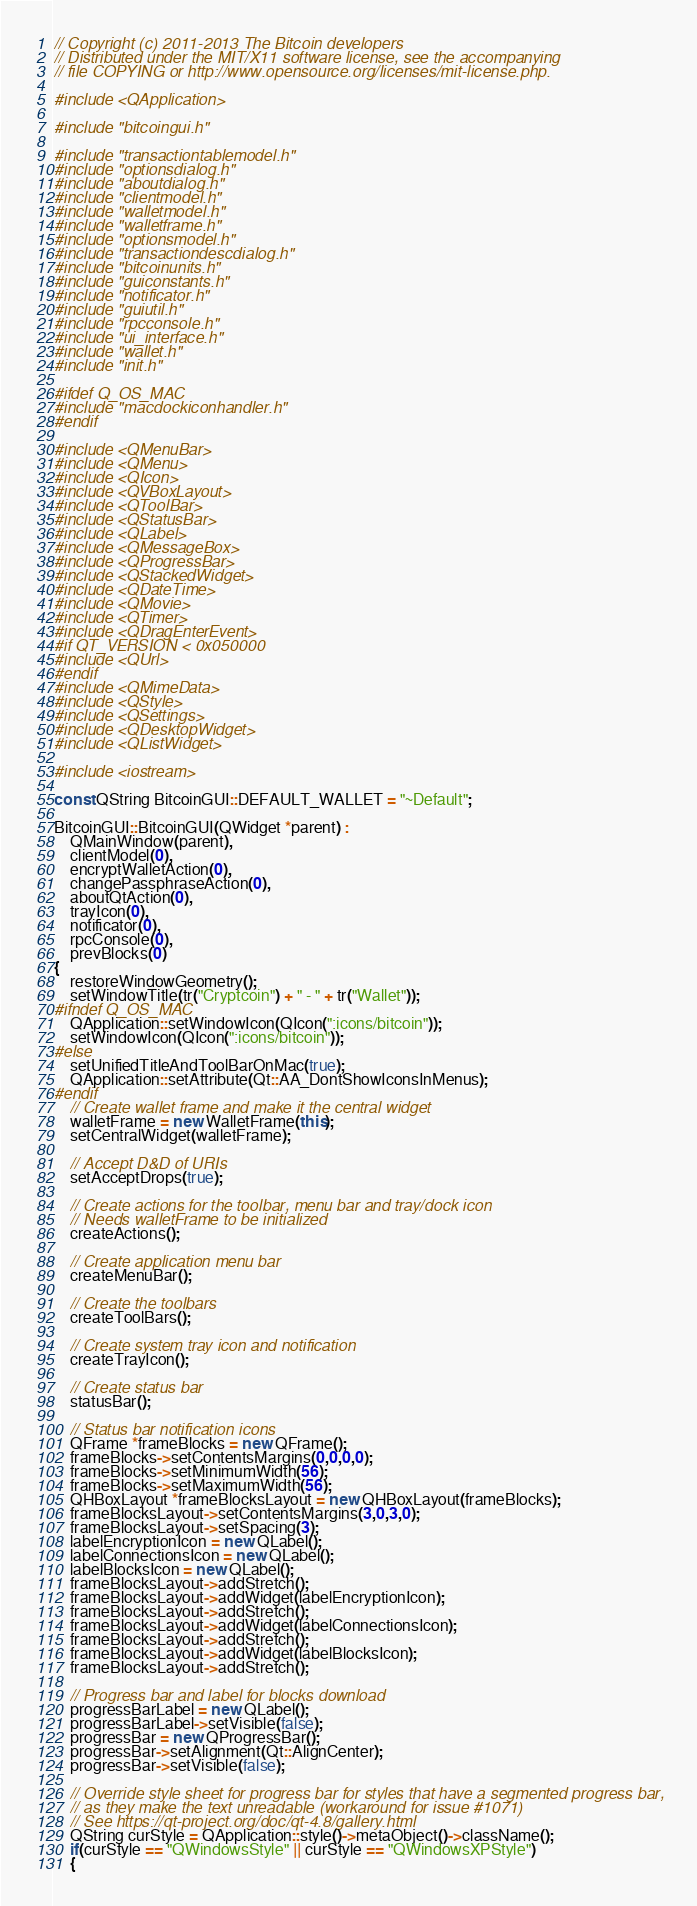Convert code to text. <code><loc_0><loc_0><loc_500><loc_500><_C++_>// Copyright (c) 2011-2013 The Bitcoin developers
// Distributed under the MIT/X11 software license, see the accompanying
// file COPYING or http://www.opensource.org/licenses/mit-license.php.

#include <QApplication>

#include "bitcoingui.h"

#include "transactiontablemodel.h"
#include "optionsdialog.h"
#include "aboutdialog.h"
#include "clientmodel.h"
#include "walletmodel.h"
#include "walletframe.h"
#include "optionsmodel.h"
#include "transactiondescdialog.h"
#include "bitcoinunits.h"
#include "guiconstants.h"
#include "notificator.h"
#include "guiutil.h"
#include "rpcconsole.h"
#include "ui_interface.h"
#include "wallet.h"
#include "init.h"

#ifdef Q_OS_MAC
#include "macdockiconhandler.h"
#endif

#include <QMenuBar>
#include <QMenu>
#include <QIcon>
#include <QVBoxLayout>
#include <QToolBar>
#include <QStatusBar>
#include <QLabel>
#include <QMessageBox>
#include <QProgressBar>
#include <QStackedWidget>
#include <QDateTime>
#include <QMovie>
#include <QTimer>
#include <QDragEnterEvent>
#if QT_VERSION < 0x050000
#include <QUrl>
#endif
#include <QMimeData>
#include <QStyle>
#include <QSettings>
#include <QDesktopWidget>
#include <QListWidget>

#include <iostream>

const QString BitcoinGUI::DEFAULT_WALLET = "~Default";

BitcoinGUI::BitcoinGUI(QWidget *parent) :
    QMainWindow(parent),
    clientModel(0),
    encryptWalletAction(0),
    changePassphraseAction(0),
    aboutQtAction(0),
    trayIcon(0),
    notificator(0),
    rpcConsole(0),
    prevBlocks(0)
{
    restoreWindowGeometry();
    setWindowTitle(tr("Cryptcoin") + " - " + tr("Wallet"));
#ifndef Q_OS_MAC
    QApplication::setWindowIcon(QIcon(":icons/bitcoin"));
    setWindowIcon(QIcon(":icons/bitcoin"));
#else
    setUnifiedTitleAndToolBarOnMac(true);
    QApplication::setAttribute(Qt::AA_DontShowIconsInMenus);
#endif
    // Create wallet frame and make it the central widget
    walletFrame = new WalletFrame(this);
    setCentralWidget(walletFrame);

    // Accept D&D of URIs
    setAcceptDrops(true);

    // Create actions for the toolbar, menu bar and tray/dock icon
    // Needs walletFrame to be initialized
    createActions();

    // Create application menu bar
    createMenuBar();

    // Create the toolbars
    createToolBars();

    // Create system tray icon and notification
    createTrayIcon();

    // Create status bar
    statusBar();

    // Status bar notification icons
    QFrame *frameBlocks = new QFrame();
    frameBlocks->setContentsMargins(0,0,0,0);
    frameBlocks->setMinimumWidth(56);
    frameBlocks->setMaximumWidth(56);
    QHBoxLayout *frameBlocksLayout = new QHBoxLayout(frameBlocks);
    frameBlocksLayout->setContentsMargins(3,0,3,0);
    frameBlocksLayout->setSpacing(3);
    labelEncryptionIcon = new QLabel();
    labelConnectionsIcon = new QLabel();
    labelBlocksIcon = new QLabel();
    frameBlocksLayout->addStretch();
    frameBlocksLayout->addWidget(labelEncryptionIcon);
    frameBlocksLayout->addStretch();
    frameBlocksLayout->addWidget(labelConnectionsIcon);
    frameBlocksLayout->addStretch();
    frameBlocksLayout->addWidget(labelBlocksIcon);
    frameBlocksLayout->addStretch();

    // Progress bar and label for blocks download
    progressBarLabel = new QLabel();
    progressBarLabel->setVisible(false);
    progressBar = new QProgressBar();
    progressBar->setAlignment(Qt::AlignCenter);
    progressBar->setVisible(false);

    // Override style sheet for progress bar for styles that have a segmented progress bar,
    // as they make the text unreadable (workaround for issue #1071)
    // See https://qt-project.org/doc/qt-4.8/gallery.html
    QString curStyle = QApplication::style()->metaObject()->className();
    if(curStyle == "QWindowsStyle" || curStyle == "QWindowsXPStyle")
    {</code> 